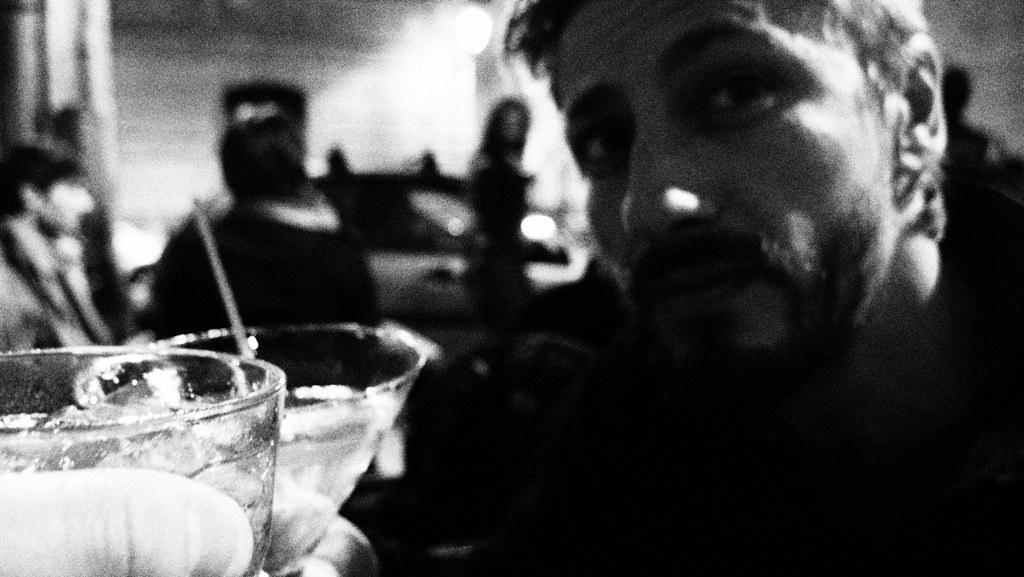What objects are located on the left side of the image? There are two glasses on the left side of the image. What can be seen on the right side of the image? There is a person on the right side of the image. Can you describe any specific details about the person's finger? A person's finger is visible on the left side of the image. How would you describe the background of the image? The background of the image is blurred. What type of joke is the person telling in the image? There is no indication of a joke being told in the image. Is there any poison visible in the image? There is no mention of poison in the image. 